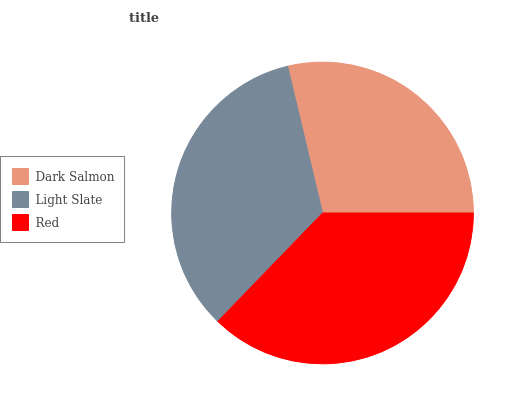Is Dark Salmon the minimum?
Answer yes or no. Yes. Is Red the maximum?
Answer yes or no. Yes. Is Light Slate the minimum?
Answer yes or no. No. Is Light Slate the maximum?
Answer yes or no. No. Is Light Slate greater than Dark Salmon?
Answer yes or no. Yes. Is Dark Salmon less than Light Slate?
Answer yes or no. Yes. Is Dark Salmon greater than Light Slate?
Answer yes or no. No. Is Light Slate less than Dark Salmon?
Answer yes or no. No. Is Light Slate the high median?
Answer yes or no. Yes. Is Light Slate the low median?
Answer yes or no. Yes. Is Red the high median?
Answer yes or no. No. Is Red the low median?
Answer yes or no. No. 